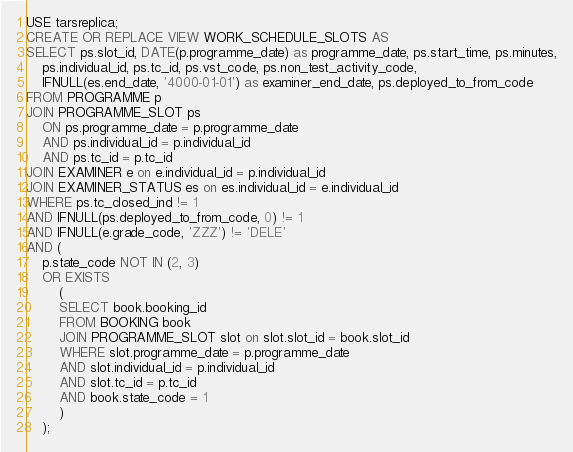<code> <loc_0><loc_0><loc_500><loc_500><_SQL_>USE tarsreplica;
CREATE OR REPLACE VIEW WORK_SCHEDULE_SLOTS AS
SELECT ps.slot_id, DATE(p.programme_date) as programme_date, ps.start_time, ps.minutes,
    ps.individual_id, ps.tc_id, ps.vst_code, ps.non_test_activity_code,
    IFNULL(es.end_date, '4000-01-01') as examiner_end_date, ps.deployed_to_from_code
FROM PROGRAMME p
JOIN PROGRAMME_SLOT ps
    ON ps.programme_date = p.programme_date
    AND ps.individual_id = p.individual_id
    AND ps.tc_id = p.tc_id
JOIN EXAMINER e on e.individual_id = p.individual_id
JOIN EXAMINER_STATUS es on es.individual_id = e.individual_id
WHERE ps.tc_closed_ind != 1
AND IFNULL(ps.deployed_to_from_code, 0) != 1
AND IFNULL(e.grade_code, 'ZZZ') != 'DELE'
AND (
    p.state_code NOT IN (2, 3)
    OR EXISTS
        (
        SELECT book.booking_id
        FROM BOOKING book
        JOIN PROGRAMME_SLOT slot on slot.slot_id = book.slot_id
        WHERE slot.programme_date = p.programme_date
        AND slot.individual_id = p.individual_id
        AND slot.tc_id = p.tc_id
        AND book.state_code = 1
        )
    );</code> 